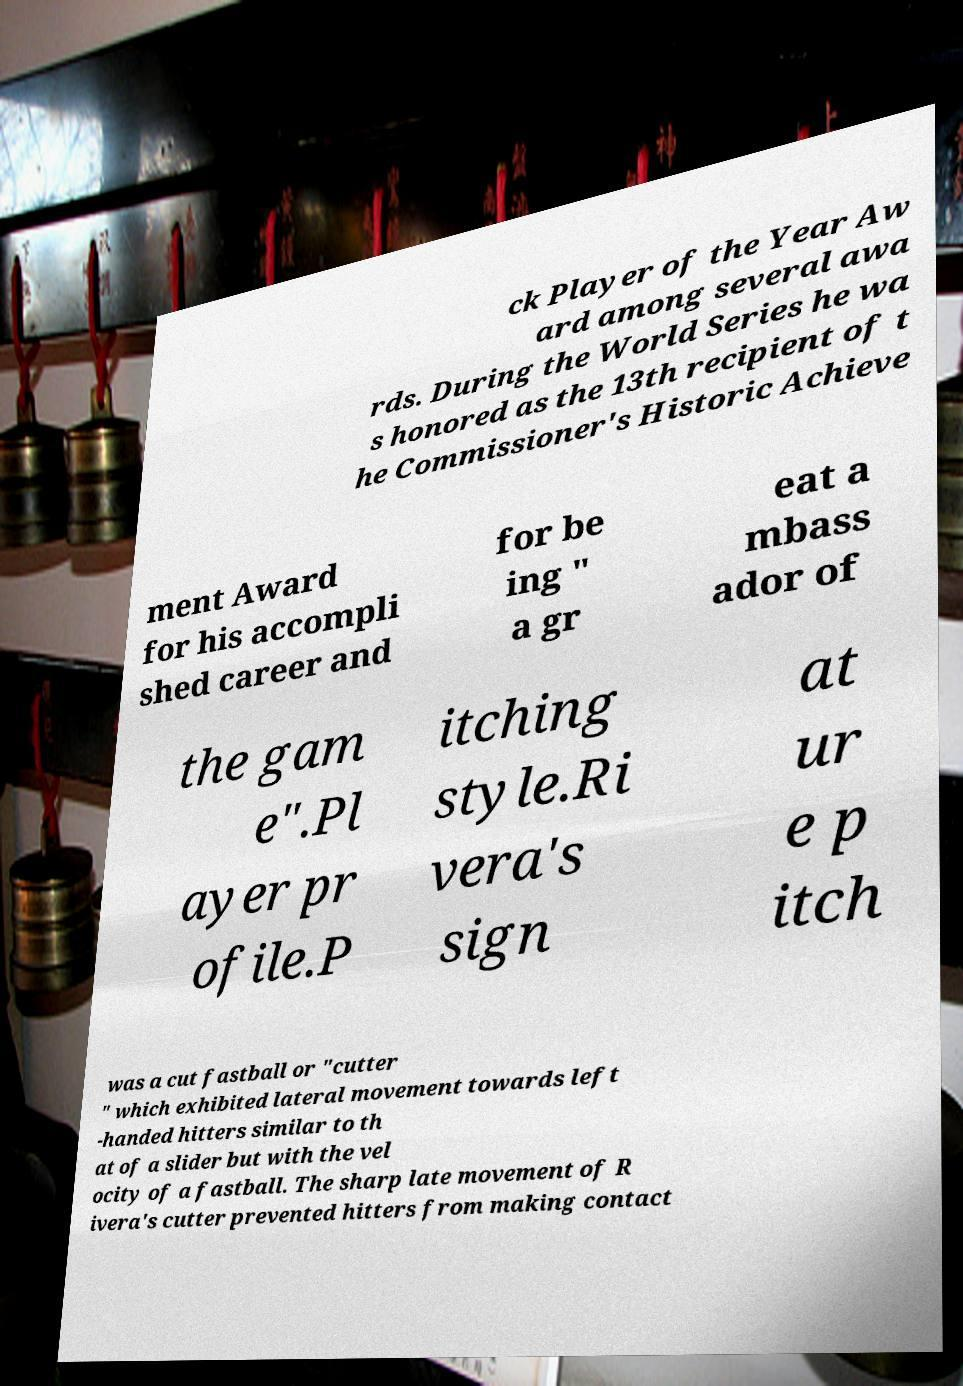Could you assist in decoding the text presented in this image and type it out clearly? ck Player of the Year Aw ard among several awa rds. During the World Series he wa s honored as the 13th recipient of t he Commissioner's Historic Achieve ment Award for his accompli shed career and for be ing " a gr eat a mbass ador of the gam e".Pl ayer pr ofile.P itching style.Ri vera's sign at ur e p itch was a cut fastball or "cutter " which exhibited lateral movement towards left -handed hitters similar to th at of a slider but with the vel ocity of a fastball. The sharp late movement of R ivera's cutter prevented hitters from making contact 